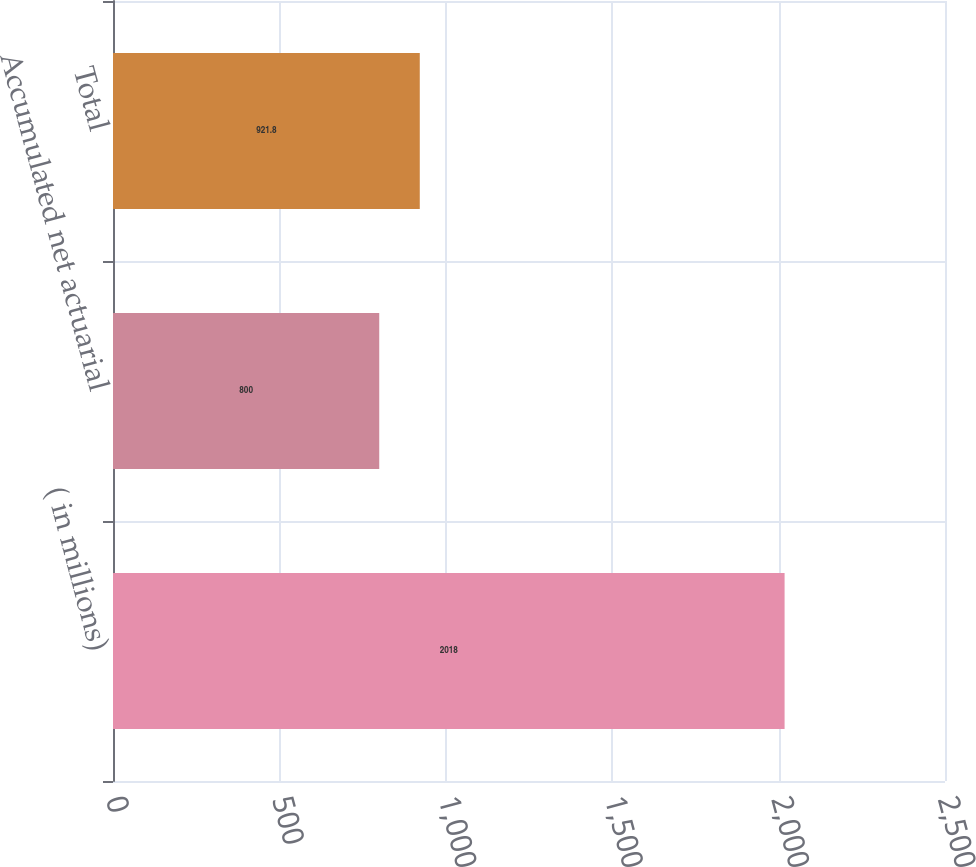Convert chart. <chart><loc_0><loc_0><loc_500><loc_500><bar_chart><fcel>( in millions)<fcel>Accumulated net actuarial<fcel>Total<nl><fcel>2018<fcel>800<fcel>921.8<nl></chart> 